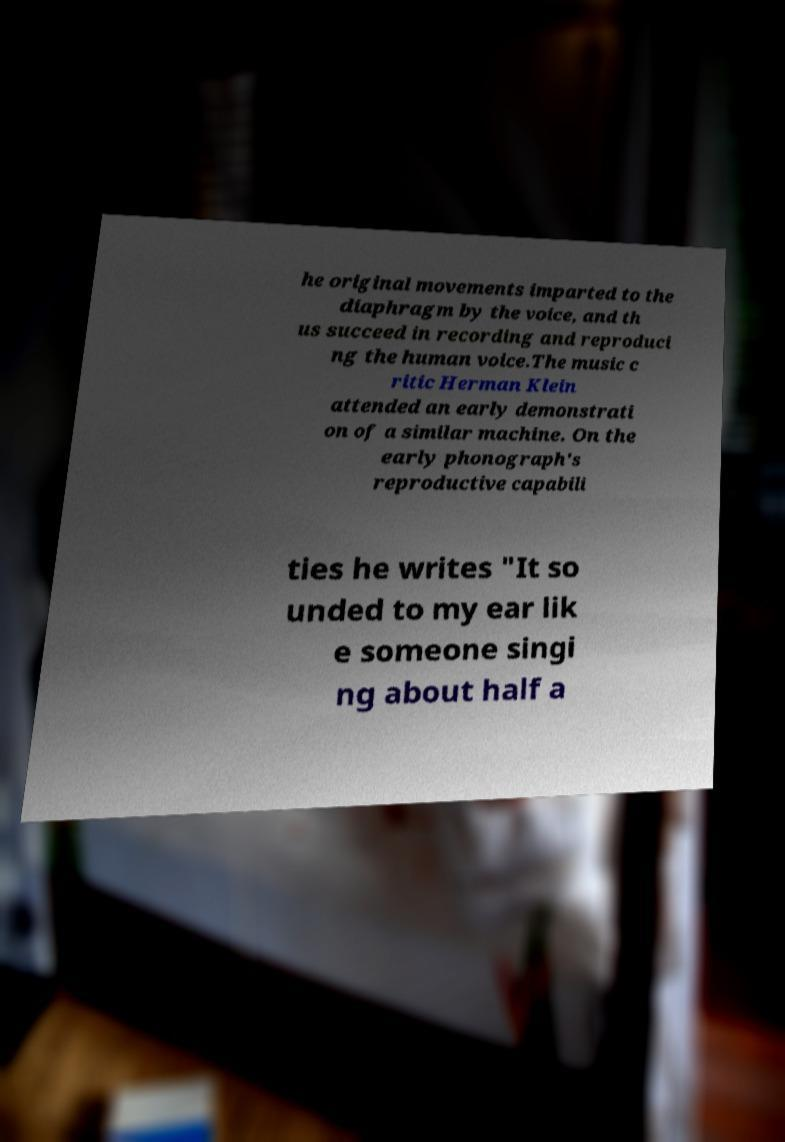Could you assist in decoding the text presented in this image and type it out clearly? he original movements imparted to the diaphragm by the voice, and th us succeed in recording and reproduci ng the human voice.The music c ritic Herman Klein attended an early demonstrati on of a similar machine. On the early phonograph's reproductive capabili ties he writes "It so unded to my ear lik e someone singi ng about half a 